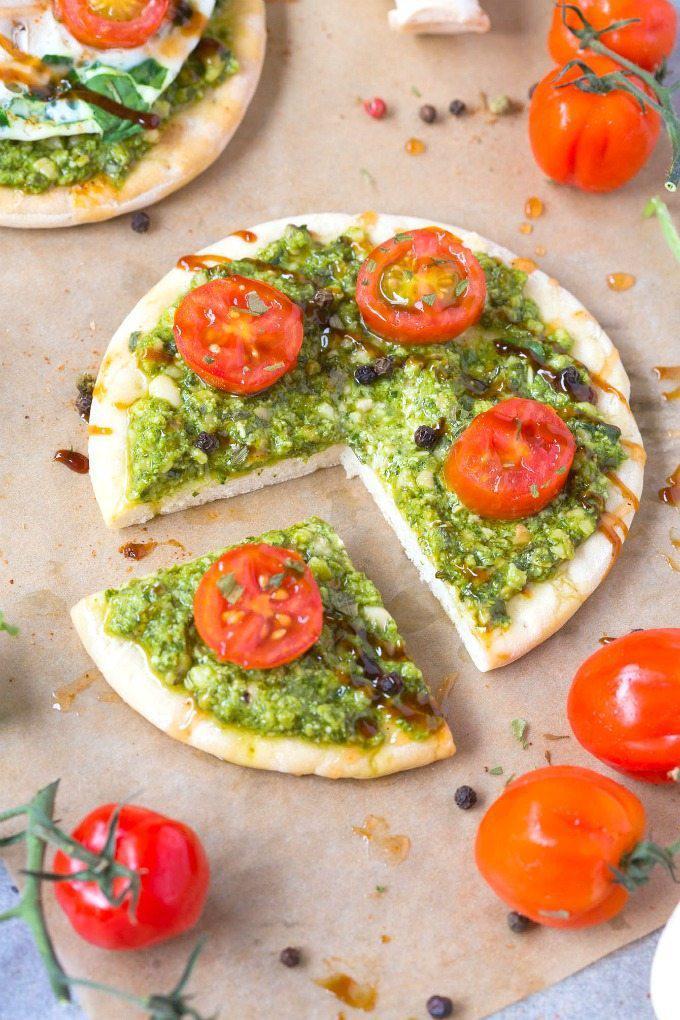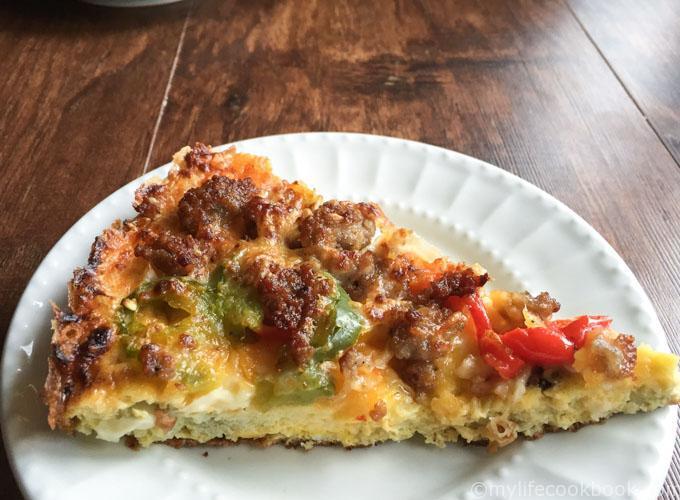The first image is the image on the left, the second image is the image on the right. For the images shown, is this caption "Fewer than two slices of pizza can be seen on a white plate." true? Answer yes or no. Yes. The first image is the image on the left, the second image is the image on the right. Considering the images on both sides, is "There are whole tomatoes next to the pizza only in the image on the left." valid? Answer yes or no. Yes. 